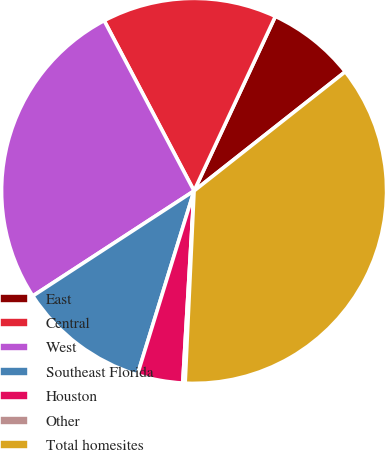Convert chart. <chart><loc_0><loc_0><loc_500><loc_500><pie_chart><fcel>East<fcel>Central<fcel>West<fcel>Southeast Florida<fcel>Houston<fcel>Other<fcel>Total homesites<nl><fcel>7.44%<fcel>14.67%<fcel>26.46%<fcel>11.05%<fcel>3.82%<fcel>0.2%<fcel>36.36%<nl></chart> 